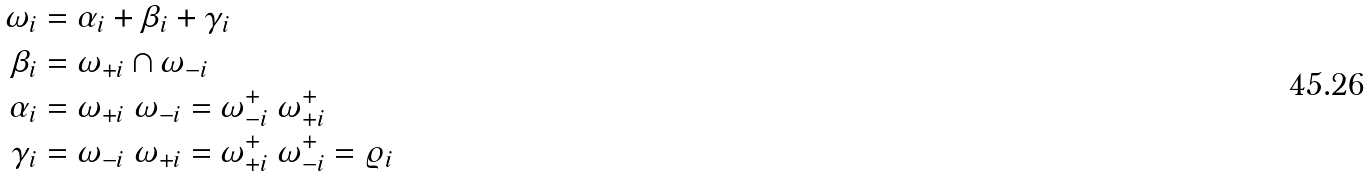<formula> <loc_0><loc_0><loc_500><loc_500>\omega _ { i } & = \alpha _ { i } + \beta _ { i } + \gamma _ { i } \\ \beta _ { i } & = \omega _ { + i } \cap \omega _ { - i } \\ \alpha _ { i } & = \omega _ { + i } \ \omega _ { - i } = \omega _ { - i } ^ { + } \ \omega _ { + i } ^ { + } \\ \gamma _ { i } & = \omega _ { - i } \ \omega _ { + i } = \omega _ { + i } ^ { + } \ \omega _ { - i } ^ { + } = \varrho _ { i }</formula> 